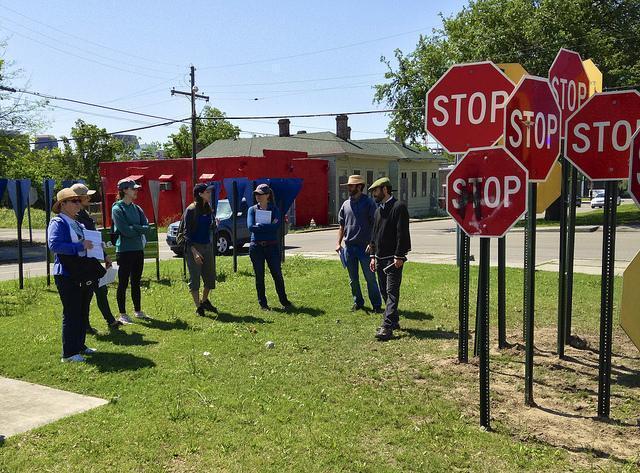Who created the works seen here?
Select the accurate answer and provide justification: `Answer: choice
Rationale: srationale.`
Options: City planning, artist, government offices, traffic department. Answer: artist.
Rationale: The traffic department created the stop signs seen here. 